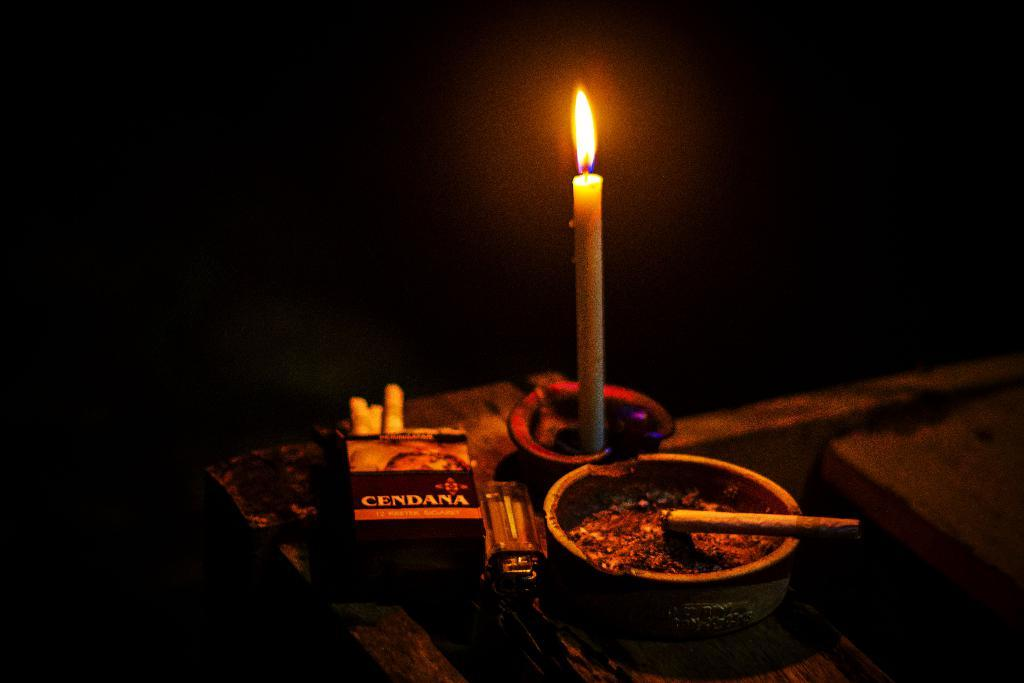What is present on the table in the image? There is a candle, cigarettes, a lighter, and an ashtray on the table. What might be used to light the candle or cigarettes in the image? The lighter on the table can be used to light the candle or cigarettes. What is the purpose of the ashtray in the image? The ashtray is present for holding cigarette ashes and butts. How would you describe the lighting conditions in the image? The background of the image is dark. Absurd Question/Answer: What type of wheel can be seen in the image? There is no wheel present in the image. How does the arithmetic problem on the table get solved in the image? There is no arithmetic problem present in the image. How does the person in the image push the object with wheels? There is no person or object with wheels present in the image. What type of arithmetic problem is being solved on the table in the image? There is no arithmetic problem present in the image. 